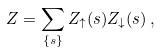<formula> <loc_0><loc_0><loc_500><loc_500>Z = \sum _ { \{ { s } \} } Z _ { \uparrow } ( { s } ) Z _ { \downarrow } ( { s } ) \, ,</formula> 